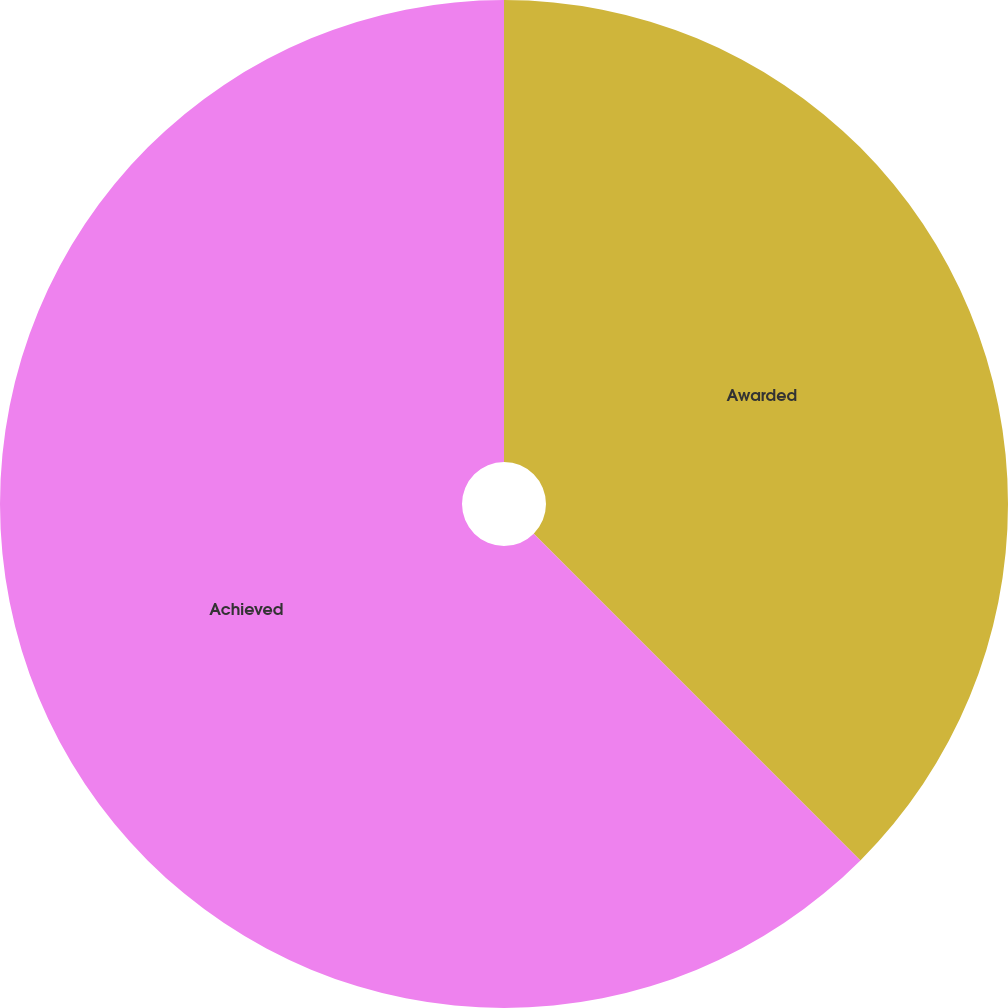<chart> <loc_0><loc_0><loc_500><loc_500><pie_chart><fcel>Awarded<fcel>Achieved<nl><fcel>37.5%<fcel>62.5%<nl></chart> 